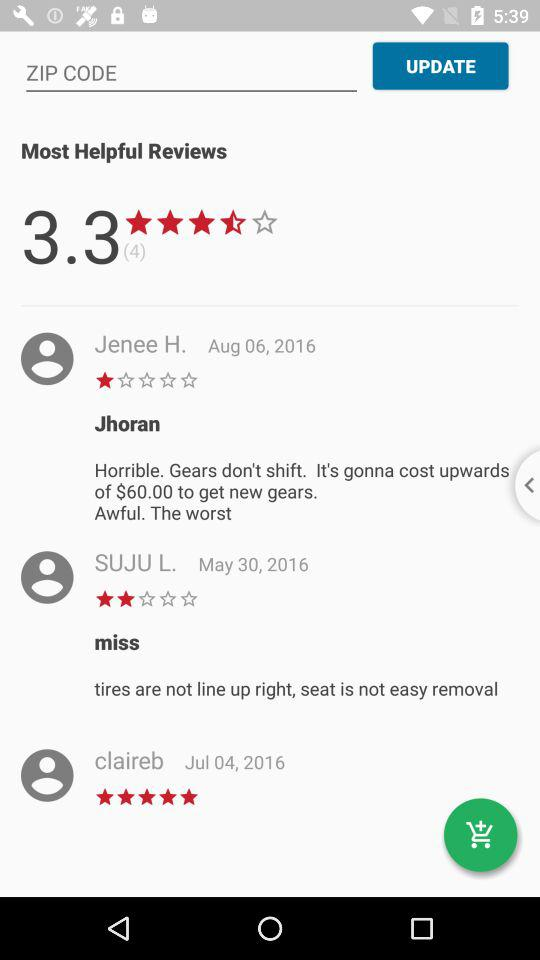What rating did Claireb's review get? Claireb's review gets 5 stars. 